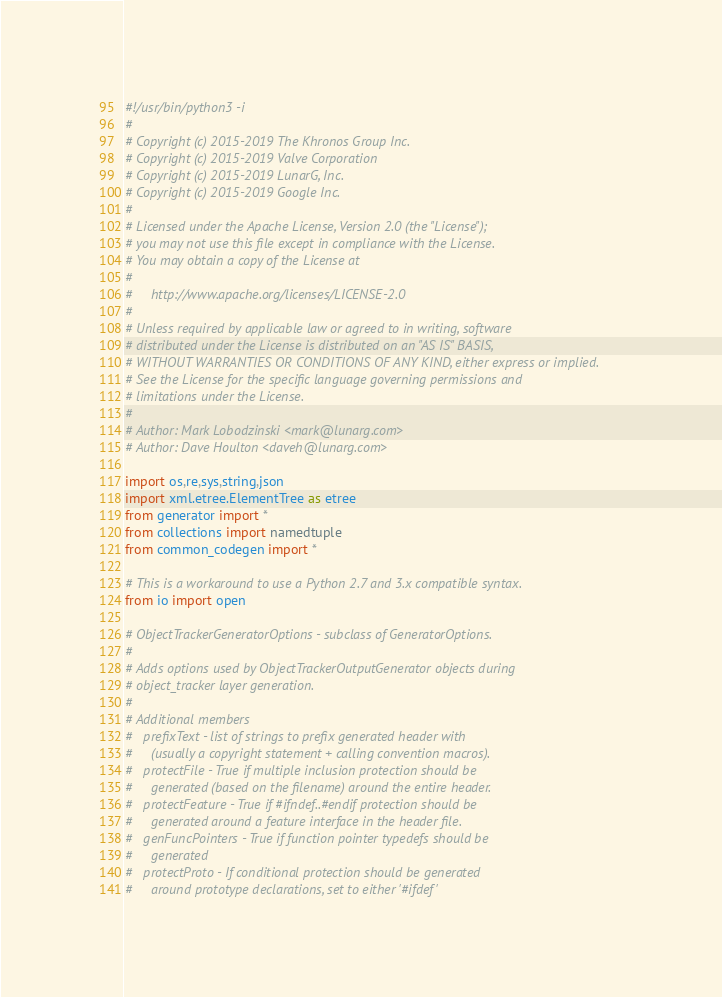<code> <loc_0><loc_0><loc_500><loc_500><_Python_>#!/usr/bin/python3 -i
#
# Copyright (c) 2015-2019 The Khronos Group Inc.
# Copyright (c) 2015-2019 Valve Corporation
# Copyright (c) 2015-2019 LunarG, Inc.
# Copyright (c) 2015-2019 Google Inc.
#
# Licensed under the Apache License, Version 2.0 (the "License");
# you may not use this file except in compliance with the License.
# You may obtain a copy of the License at
#
#     http://www.apache.org/licenses/LICENSE-2.0
#
# Unless required by applicable law or agreed to in writing, software
# distributed under the License is distributed on an "AS IS" BASIS,
# WITHOUT WARRANTIES OR CONDITIONS OF ANY KIND, either express or implied.
# See the License for the specific language governing permissions and
# limitations under the License.
#
# Author: Mark Lobodzinski <mark@lunarg.com>
# Author: Dave Houlton <daveh@lunarg.com>

import os,re,sys,string,json
import xml.etree.ElementTree as etree
from generator import *
from collections import namedtuple
from common_codegen import *

# This is a workaround to use a Python 2.7 and 3.x compatible syntax.
from io import open

# ObjectTrackerGeneratorOptions - subclass of GeneratorOptions.
#
# Adds options used by ObjectTrackerOutputGenerator objects during
# object_tracker layer generation.
#
# Additional members
#   prefixText - list of strings to prefix generated header with
#     (usually a copyright statement + calling convention macros).
#   protectFile - True if multiple inclusion protection should be
#     generated (based on the filename) around the entire header.
#   protectFeature - True if #ifndef..#endif protection should be
#     generated around a feature interface in the header file.
#   genFuncPointers - True if function pointer typedefs should be
#     generated
#   protectProto - If conditional protection should be generated
#     around prototype declarations, set to either '#ifdef'</code> 